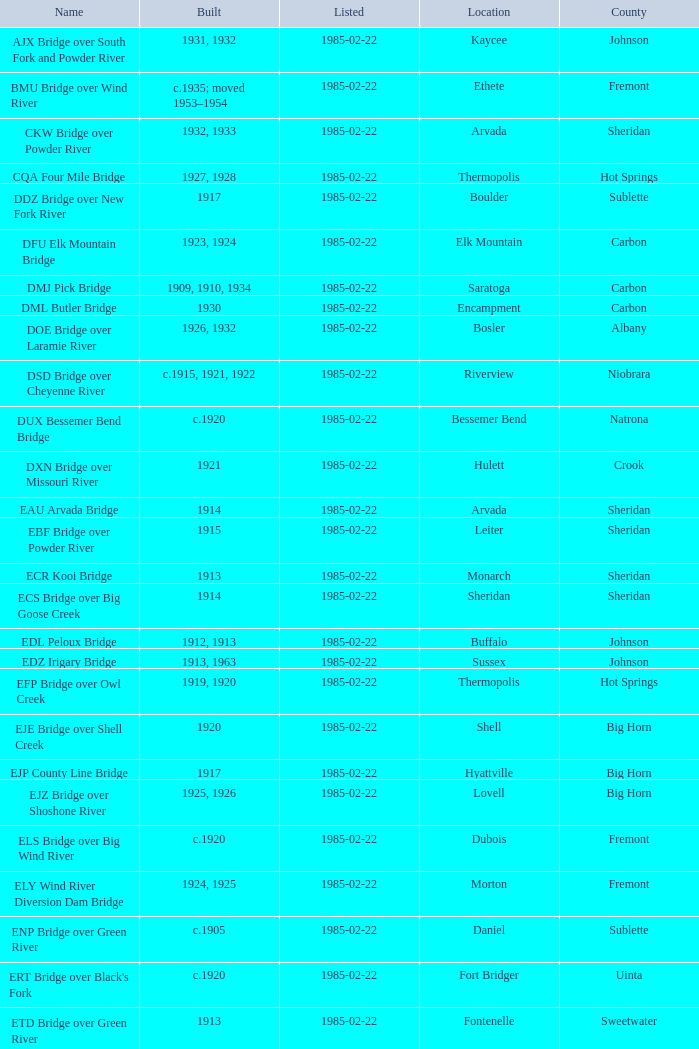What is the county of the bridge in Boulder? Sublette. 